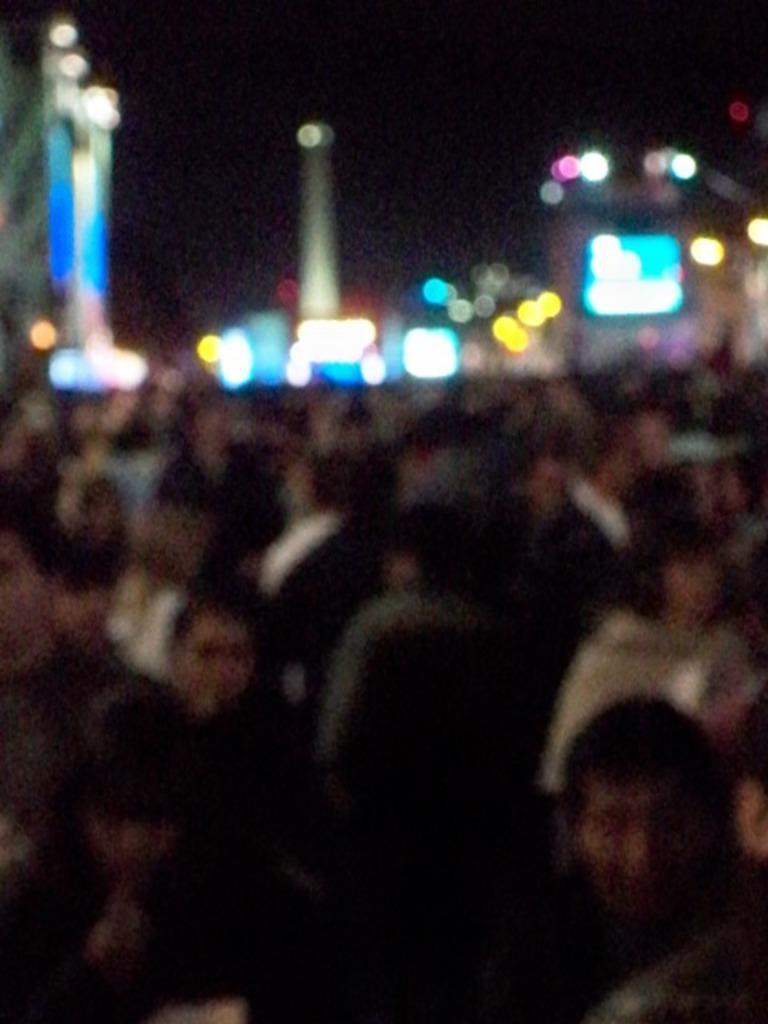Please provide a concise description of this image. It is a blur image. In this image, we can see a group of people and lights. Background there is a dark view. 